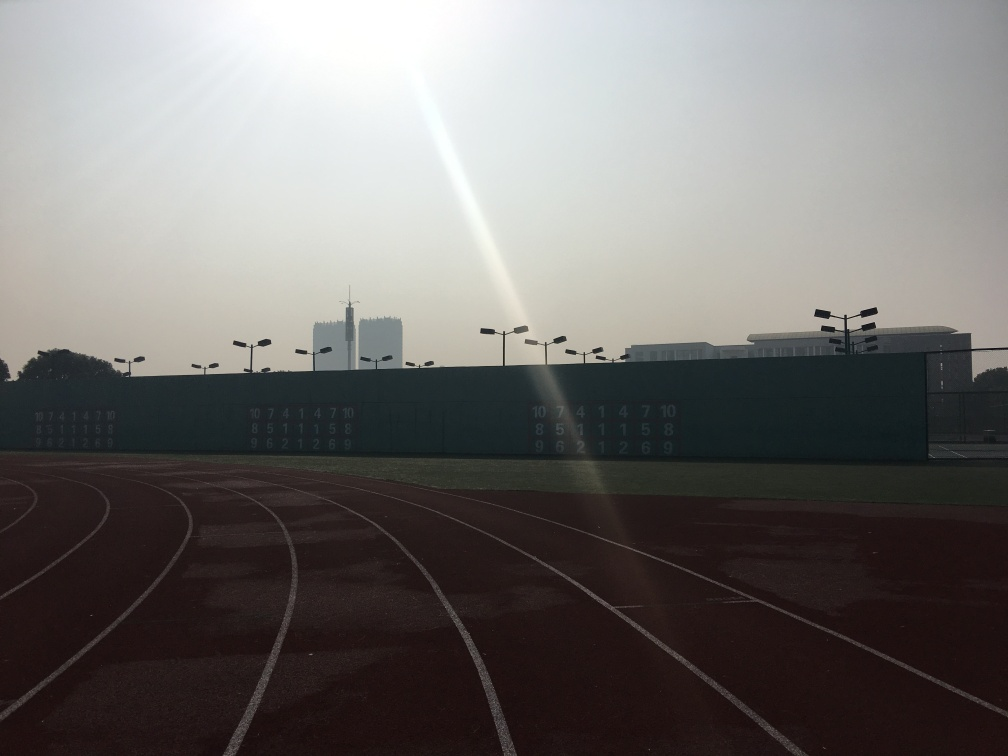What is the composition of this image?
A. The composition is excellent.
B. The composition is poor.
C. The composition is average. The composition of this image could be considered average; however, it exhibits some elements of strong visual interest. The track leads the eye through the image, with the lines creating a sense of movement and direction. The sun's position creates a backlight effect, casting a lens flare that adds a dramatic touch, yet this may also be seen as a technical flaw by some. The contrast between the shadows and the bright sky lends the photo depth, but the overall lighting is somewhat flat, and the image lacks a clear focal point which may not fully capitalize on its potential for a striking composition. 